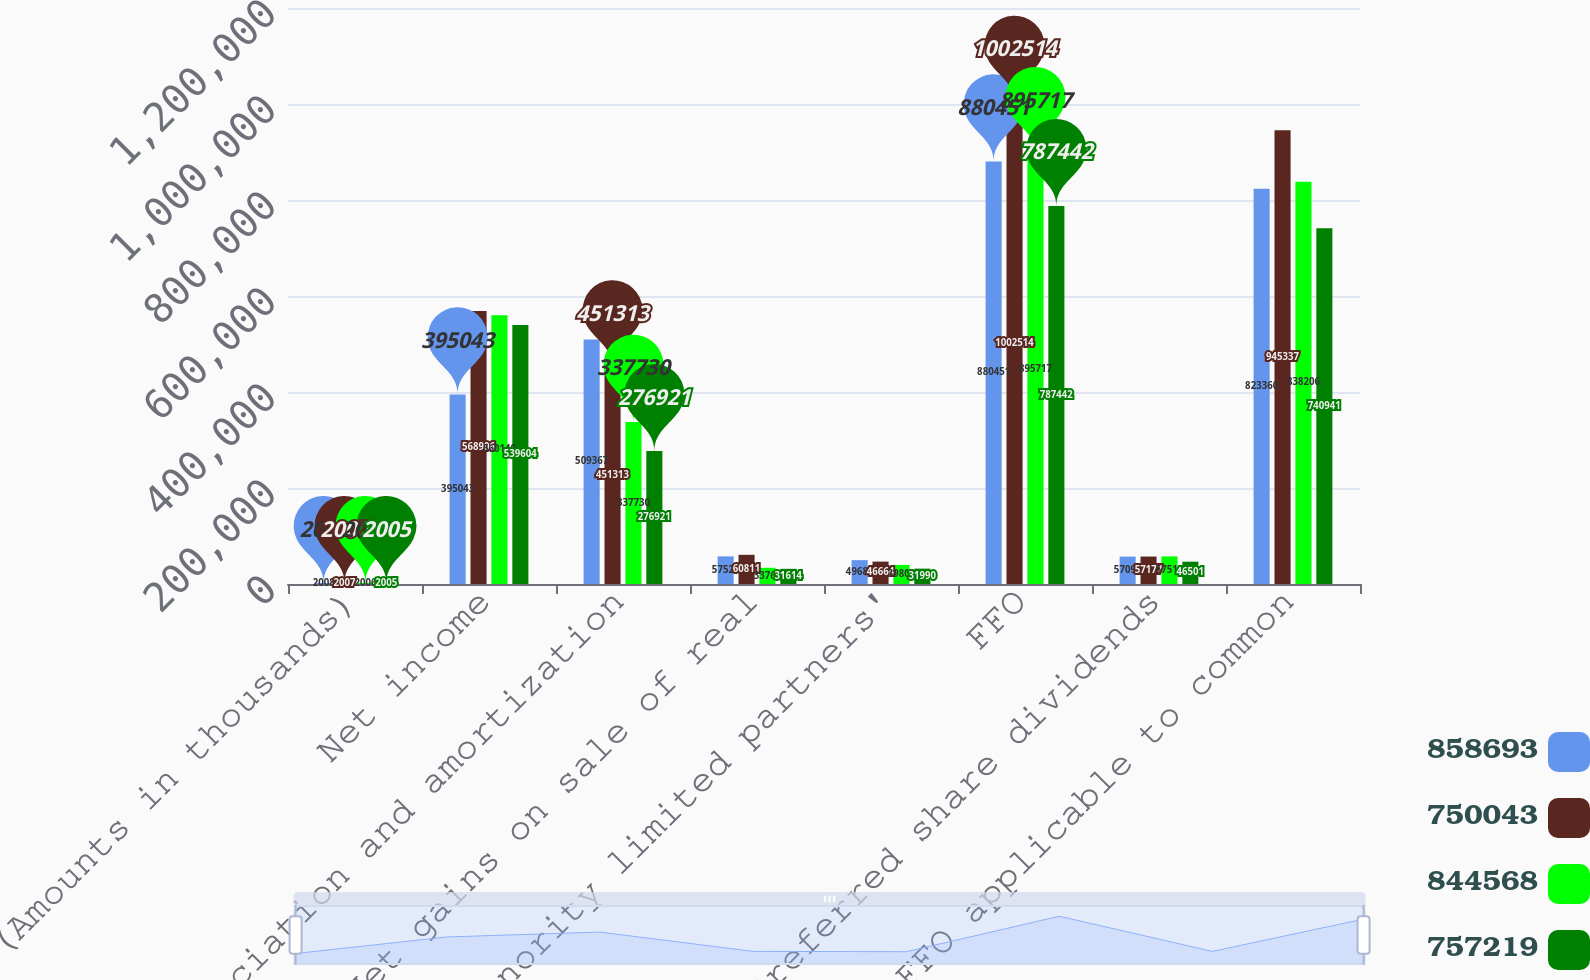Convert chart. <chart><loc_0><loc_0><loc_500><loc_500><stacked_bar_chart><ecel><fcel>(Amounts in thousands)<fcel>Net income<fcel>Depreciation and amortization<fcel>Net gains on sale of real<fcel>Minority limited partners'<fcel>FFO<fcel>Preferred share dividends<fcel>FFO applicable to common<nl><fcel>858693<fcel>2008<fcel>395043<fcel>509367<fcel>57523<fcel>49683<fcel>880451<fcel>57091<fcel>823360<nl><fcel>750043<fcel>2007<fcel>568906<fcel>451313<fcel>60811<fcel>46664<fcel>1.00251e+06<fcel>57177<fcel>945337<nl><fcel>844568<fcel>2006<fcel>560140<fcel>337730<fcel>33769<fcel>39809<fcel>895717<fcel>57511<fcel>838206<nl><fcel>757219<fcel>2005<fcel>539604<fcel>276921<fcel>31614<fcel>31990<fcel>787442<fcel>46501<fcel>740941<nl></chart> 